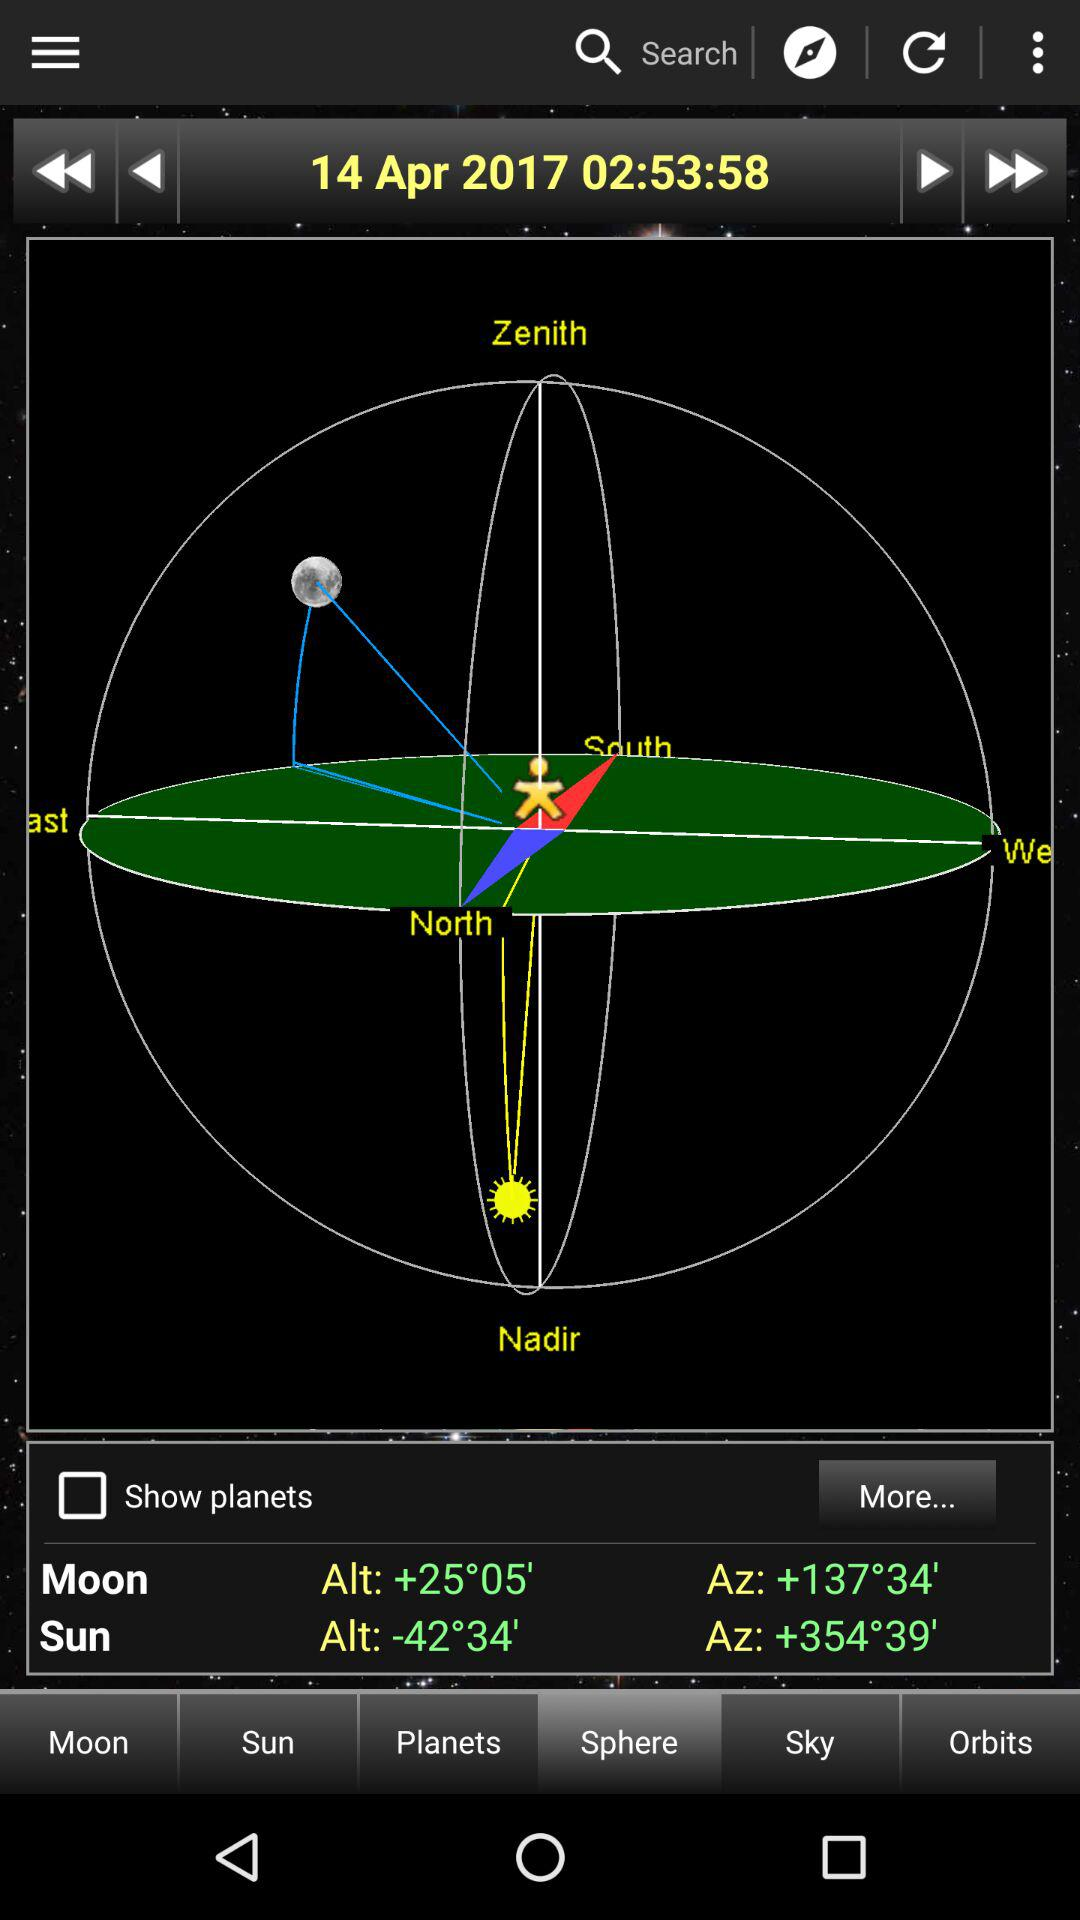What date is displayed on the screen? The date displayed on the screen is April 14, 2017. 